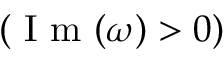Convert formula to latex. <formula><loc_0><loc_0><loc_500><loc_500>( I m ( \omega ) > 0 )</formula> 